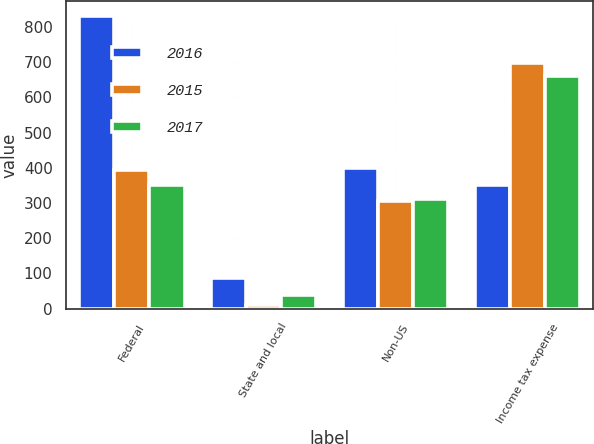<chart> <loc_0><loc_0><loc_500><loc_500><stacked_bar_chart><ecel><fcel>Federal<fcel>State and local<fcel>Non-US<fcel>Income tax expense<nl><fcel>2016<fcel>831<fcel>86<fcel>398<fcel>351<nl><fcel>2015<fcel>394<fcel>11<fcel>305<fcel>697<nl><fcel>2017<fcel>351<fcel>40<fcel>311<fcel>660<nl></chart> 